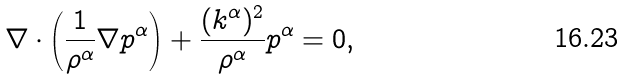Convert formula to latex. <formula><loc_0><loc_0><loc_500><loc_500>\nabla \cdot \left ( \frac { 1 } { \rho ^ { \alpha } } \nabla p ^ { \alpha } \right ) + \frac { ( k ^ { \alpha } ) ^ { 2 } } { \rho ^ { \alpha } } p ^ { \alpha } = 0 ,</formula> 